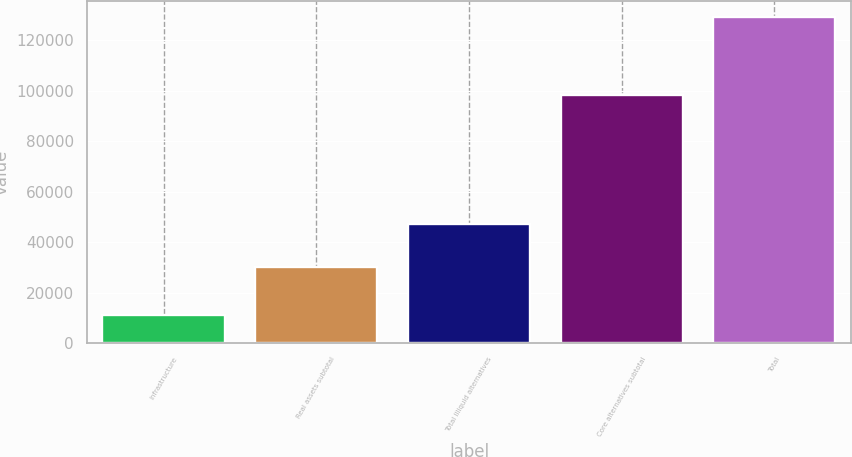Convert chart to OTSL. <chart><loc_0><loc_0><loc_500><loc_500><bar_chart><fcel>Infrastructure<fcel>Real assets subtotal<fcel>Total Illiquid alternatives<fcel>Core alternatives subtotal<fcel>Total<nl><fcel>11328<fcel>30272<fcel>47270<fcel>98533<fcel>129347<nl></chart> 